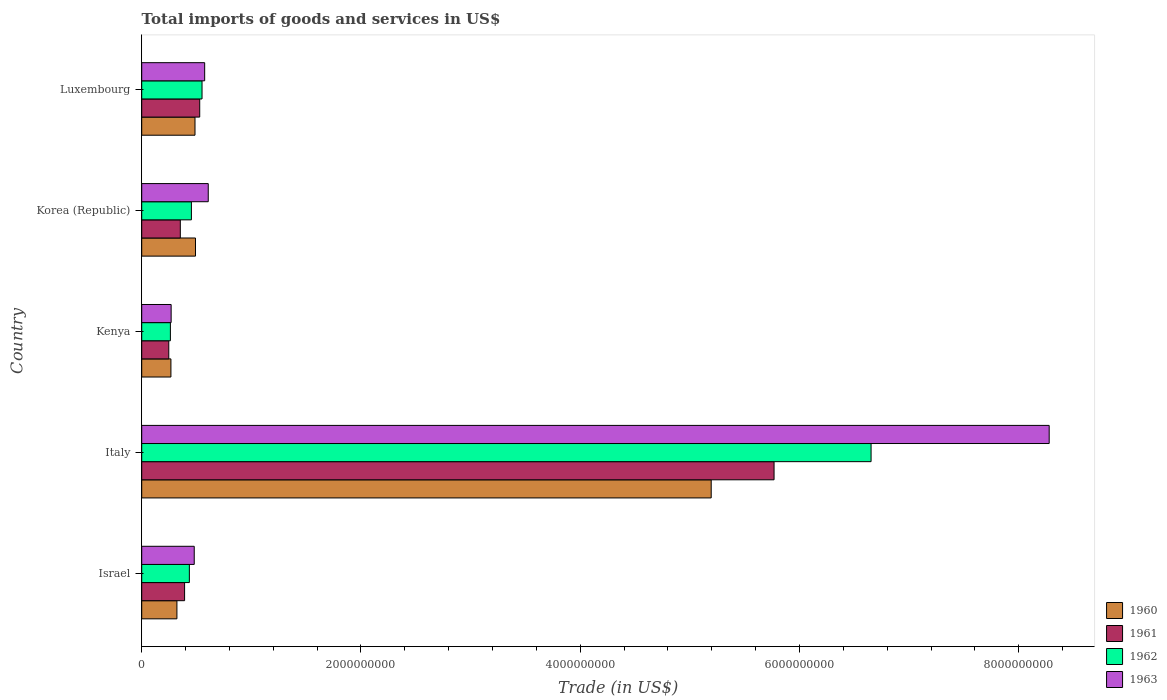How many different coloured bars are there?
Make the answer very short. 4. How many groups of bars are there?
Offer a terse response. 5. How many bars are there on the 4th tick from the bottom?
Keep it short and to the point. 4. What is the label of the 3rd group of bars from the top?
Your answer should be very brief. Kenya. What is the total imports of goods and services in 1960 in Israel?
Give a very brief answer. 3.21e+08. Across all countries, what is the maximum total imports of goods and services in 1963?
Offer a very short reply. 8.28e+09. Across all countries, what is the minimum total imports of goods and services in 1962?
Give a very brief answer. 2.62e+08. In which country was the total imports of goods and services in 1960 maximum?
Give a very brief answer. Italy. In which country was the total imports of goods and services in 1961 minimum?
Your answer should be very brief. Kenya. What is the total total imports of goods and services in 1963 in the graph?
Your response must be concise. 1.02e+1. What is the difference between the total imports of goods and services in 1961 in Kenya and that in Luxembourg?
Your response must be concise. -2.82e+08. What is the difference between the total imports of goods and services in 1962 in Kenya and the total imports of goods and services in 1961 in Korea (Republic)?
Your response must be concise. -9.05e+07. What is the average total imports of goods and services in 1962 per country?
Provide a short and direct response. 1.67e+09. What is the difference between the total imports of goods and services in 1961 and total imports of goods and services in 1960 in Kenya?
Keep it short and to the point. -1.96e+07. In how many countries, is the total imports of goods and services in 1962 greater than 7600000000 US$?
Provide a short and direct response. 0. What is the ratio of the total imports of goods and services in 1962 in Israel to that in Italy?
Your response must be concise. 0.07. Is the total imports of goods and services in 1963 in Kenya less than that in Korea (Republic)?
Give a very brief answer. Yes. Is the difference between the total imports of goods and services in 1961 in Israel and Korea (Republic) greater than the difference between the total imports of goods and services in 1960 in Israel and Korea (Republic)?
Provide a short and direct response. Yes. What is the difference between the highest and the second highest total imports of goods and services in 1960?
Keep it short and to the point. 4.70e+09. What is the difference between the highest and the lowest total imports of goods and services in 1963?
Ensure brevity in your answer.  8.01e+09. Is the sum of the total imports of goods and services in 1960 in Kenya and Korea (Republic) greater than the maximum total imports of goods and services in 1963 across all countries?
Make the answer very short. No. Is it the case that in every country, the sum of the total imports of goods and services in 1962 and total imports of goods and services in 1961 is greater than the sum of total imports of goods and services in 1963 and total imports of goods and services in 1960?
Keep it short and to the point. No. What does the 3rd bar from the top in Kenya represents?
Keep it short and to the point. 1961. Is it the case that in every country, the sum of the total imports of goods and services in 1963 and total imports of goods and services in 1962 is greater than the total imports of goods and services in 1961?
Your answer should be very brief. Yes. How many bars are there?
Your answer should be compact. 20. Are all the bars in the graph horizontal?
Keep it short and to the point. Yes. How many countries are there in the graph?
Offer a terse response. 5. Are the values on the major ticks of X-axis written in scientific E-notation?
Provide a short and direct response. No. Does the graph contain grids?
Your answer should be compact. No. How many legend labels are there?
Offer a very short reply. 4. How are the legend labels stacked?
Provide a succinct answer. Vertical. What is the title of the graph?
Your answer should be compact. Total imports of goods and services in US$. Does "2014" appear as one of the legend labels in the graph?
Your answer should be very brief. No. What is the label or title of the X-axis?
Offer a terse response. Trade (in US$). What is the label or title of the Y-axis?
Provide a short and direct response. Country. What is the Trade (in US$) in 1960 in Israel?
Offer a very short reply. 3.21e+08. What is the Trade (in US$) in 1961 in Israel?
Keep it short and to the point. 3.91e+08. What is the Trade (in US$) of 1962 in Israel?
Provide a succinct answer. 4.34e+08. What is the Trade (in US$) in 1963 in Israel?
Offer a very short reply. 4.79e+08. What is the Trade (in US$) in 1960 in Italy?
Make the answer very short. 5.19e+09. What is the Trade (in US$) in 1961 in Italy?
Provide a succinct answer. 5.77e+09. What is the Trade (in US$) of 1962 in Italy?
Offer a terse response. 6.65e+09. What is the Trade (in US$) of 1963 in Italy?
Your answer should be very brief. 8.28e+09. What is the Trade (in US$) in 1960 in Kenya?
Your answer should be compact. 2.66e+08. What is the Trade (in US$) of 1961 in Kenya?
Your answer should be compact. 2.47e+08. What is the Trade (in US$) of 1962 in Kenya?
Your answer should be very brief. 2.62e+08. What is the Trade (in US$) in 1963 in Kenya?
Give a very brief answer. 2.68e+08. What is the Trade (in US$) of 1960 in Korea (Republic)?
Your answer should be compact. 4.90e+08. What is the Trade (in US$) of 1961 in Korea (Republic)?
Offer a very short reply. 3.52e+08. What is the Trade (in US$) of 1962 in Korea (Republic)?
Offer a very short reply. 4.53e+08. What is the Trade (in US$) in 1963 in Korea (Republic)?
Offer a terse response. 6.07e+08. What is the Trade (in US$) in 1960 in Luxembourg?
Your response must be concise. 4.86e+08. What is the Trade (in US$) of 1961 in Luxembourg?
Provide a short and direct response. 5.29e+08. What is the Trade (in US$) of 1962 in Luxembourg?
Your answer should be compact. 5.50e+08. What is the Trade (in US$) in 1963 in Luxembourg?
Give a very brief answer. 5.74e+08. Across all countries, what is the maximum Trade (in US$) in 1960?
Give a very brief answer. 5.19e+09. Across all countries, what is the maximum Trade (in US$) in 1961?
Keep it short and to the point. 5.77e+09. Across all countries, what is the maximum Trade (in US$) in 1962?
Ensure brevity in your answer.  6.65e+09. Across all countries, what is the maximum Trade (in US$) of 1963?
Give a very brief answer. 8.28e+09. Across all countries, what is the minimum Trade (in US$) of 1960?
Offer a terse response. 2.66e+08. Across all countries, what is the minimum Trade (in US$) in 1961?
Provide a succinct answer. 2.47e+08. Across all countries, what is the minimum Trade (in US$) of 1962?
Offer a terse response. 2.62e+08. Across all countries, what is the minimum Trade (in US$) in 1963?
Ensure brevity in your answer.  2.68e+08. What is the total Trade (in US$) in 1960 in the graph?
Offer a terse response. 6.76e+09. What is the total Trade (in US$) in 1961 in the graph?
Offer a terse response. 7.29e+09. What is the total Trade (in US$) in 1962 in the graph?
Make the answer very short. 8.35e+09. What is the total Trade (in US$) in 1963 in the graph?
Keep it short and to the point. 1.02e+1. What is the difference between the Trade (in US$) of 1960 in Israel and that in Italy?
Offer a terse response. -4.87e+09. What is the difference between the Trade (in US$) of 1961 in Israel and that in Italy?
Your response must be concise. -5.38e+09. What is the difference between the Trade (in US$) in 1962 in Israel and that in Italy?
Give a very brief answer. -6.22e+09. What is the difference between the Trade (in US$) of 1963 in Israel and that in Italy?
Provide a succinct answer. -7.80e+09. What is the difference between the Trade (in US$) in 1960 in Israel and that in Kenya?
Your response must be concise. 5.47e+07. What is the difference between the Trade (in US$) of 1961 in Israel and that in Kenya?
Provide a succinct answer. 1.44e+08. What is the difference between the Trade (in US$) in 1962 in Israel and that in Kenya?
Give a very brief answer. 1.73e+08. What is the difference between the Trade (in US$) in 1963 in Israel and that in Kenya?
Make the answer very short. 2.11e+08. What is the difference between the Trade (in US$) of 1960 in Israel and that in Korea (Republic)?
Offer a very short reply. -1.69e+08. What is the difference between the Trade (in US$) in 1961 in Israel and that in Korea (Republic)?
Provide a succinct answer. 3.90e+07. What is the difference between the Trade (in US$) of 1962 in Israel and that in Korea (Republic)?
Give a very brief answer. -1.87e+07. What is the difference between the Trade (in US$) of 1963 in Israel and that in Korea (Republic)?
Your answer should be compact. -1.28e+08. What is the difference between the Trade (in US$) of 1960 in Israel and that in Luxembourg?
Ensure brevity in your answer.  -1.65e+08. What is the difference between the Trade (in US$) in 1961 in Israel and that in Luxembourg?
Provide a short and direct response. -1.38e+08. What is the difference between the Trade (in US$) of 1962 in Israel and that in Luxembourg?
Make the answer very short. -1.16e+08. What is the difference between the Trade (in US$) in 1963 in Israel and that in Luxembourg?
Your response must be concise. -9.52e+07. What is the difference between the Trade (in US$) in 1960 in Italy and that in Kenya?
Keep it short and to the point. 4.93e+09. What is the difference between the Trade (in US$) in 1961 in Italy and that in Kenya?
Your answer should be compact. 5.52e+09. What is the difference between the Trade (in US$) of 1962 in Italy and that in Kenya?
Make the answer very short. 6.39e+09. What is the difference between the Trade (in US$) in 1963 in Italy and that in Kenya?
Keep it short and to the point. 8.01e+09. What is the difference between the Trade (in US$) in 1960 in Italy and that in Korea (Republic)?
Offer a very short reply. 4.70e+09. What is the difference between the Trade (in US$) of 1961 in Italy and that in Korea (Republic)?
Your response must be concise. 5.42e+09. What is the difference between the Trade (in US$) of 1962 in Italy and that in Korea (Republic)?
Your answer should be very brief. 6.20e+09. What is the difference between the Trade (in US$) in 1963 in Italy and that in Korea (Republic)?
Give a very brief answer. 7.67e+09. What is the difference between the Trade (in US$) in 1960 in Italy and that in Luxembourg?
Provide a short and direct response. 4.71e+09. What is the difference between the Trade (in US$) of 1961 in Italy and that in Luxembourg?
Ensure brevity in your answer.  5.24e+09. What is the difference between the Trade (in US$) in 1962 in Italy and that in Luxembourg?
Keep it short and to the point. 6.10e+09. What is the difference between the Trade (in US$) in 1963 in Italy and that in Luxembourg?
Keep it short and to the point. 7.70e+09. What is the difference between the Trade (in US$) of 1960 in Kenya and that in Korea (Republic)?
Provide a succinct answer. -2.24e+08. What is the difference between the Trade (in US$) in 1961 in Kenya and that in Korea (Republic)?
Ensure brevity in your answer.  -1.05e+08. What is the difference between the Trade (in US$) of 1962 in Kenya and that in Korea (Republic)?
Offer a very short reply. -1.92e+08. What is the difference between the Trade (in US$) of 1963 in Kenya and that in Korea (Republic)?
Offer a very short reply. -3.38e+08. What is the difference between the Trade (in US$) of 1960 in Kenya and that in Luxembourg?
Keep it short and to the point. -2.20e+08. What is the difference between the Trade (in US$) of 1961 in Kenya and that in Luxembourg?
Your response must be concise. -2.82e+08. What is the difference between the Trade (in US$) of 1962 in Kenya and that in Luxembourg?
Give a very brief answer. -2.89e+08. What is the difference between the Trade (in US$) in 1963 in Kenya and that in Luxembourg?
Your answer should be very brief. -3.06e+08. What is the difference between the Trade (in US$) in 1960 in Korea (Republic) and that in Luxembourg?
Provide a short and direct response. 4.40e+06. What is the difference between the Trade (in US$) of 1961 in Korea (Republic) and that in Luxembourg?
Provide a short and direct response. -1.77e+08. What is the difference between the Trade (in US$) of 1962 in Korea (Republic) and that in Luxembourg?
Offer a terse response. -9.70e+07. What is the difference between the Trade (in US$) of 1963 in Korea (Republic) and that in Luxembourg?
Ensure brevity in your answer.  3.26e+07. What is the difference between the Trade (in US$) of 1960 in Israel and the Trade (in US$) of 1961 in Italy?
Offer a terse response. -5.45e+09. What is the difference between the Trade (in US$) of 1960 in Israel and the Trade (in US$) of 1962 in Italy?
Your answer should be very brief. -6.33e+09. What is the difference between the Trade (in US$) of 1960 in Israel and the Trade (in US$) of 1963 in Italy?
Provide a short and direct response. -7.96e+09. What is the difference between the Trade (in US$) of 1961 in Israel and the Trade (in US$) of 1962 in Italy?
Your response must be concise. -6.26e+09. What is the difference between the Trade (in US$) in 1961 in Israel and the Trade (in US$) in 1963 in Italy?
Provide a succinct answer. -7.89e+09. What is the difference between the Trade (in US$) of 1962 in Israel and the Trade (in US$) of 1963 in Italy?
Provide a succinct answer. -7.84e+09. What is the difference between the Trade (in US$) in 1960 in Israel and the Trade (in US$) in 1961 in Kenya?
Offer a very short reply. 7.43e+07. What is the difference between the Trade (in US$) in 1960 in Israel and the Trade (in US$) in 1962 in Kenya?
Provide a short and direct response. 5.96e+07. What is the difference between the Trade (in US$) of 1960 in Israel and the Trade (in US$) of 1963 in Kenya?
Your response must be concise. 5.27e+07. What is the difference between the Trade (in US$) of 1961 in Israel and the Trade (in US$) of 1962 in Kenya?
Your answer should be very brief. 1.30e+08. What is the difference between the Trade (in US$) in 1961 in Israel and the Trade (in US$) in 1963 in Kenya?
Provide a succinct answer. 1.23e+08. What is the difference between the Trade (in US$) in 1962 in Israel and the Trade (in US$) in 1963 in Kenya?
Offer a terse response. 1.66e+08. What is the difference between the Trade (in US$) in 1960 in Israel and the Trade (in US$) in 1961 in Korea (Republic)?
Offer a very short reply. -3.10e+07. What is the difference between the Trade (in US$) in 1960 in Israel and the Trade (in US$) in 1962 in Korea (Republic)?
Your response must be concise. -1.32e+08. What is the difference between the Trade (in US$) in 1960 in Israel and the Trade (in US$) in 1963 in Korea (Republic)?
Offer a very short reply. -2.86e+08. What is the difference between the Trade (in US$) in 1961 in Israel and the Trade (in US$) in 1962 in Korea (Republic)?
Your answer should be compact. -6.21e+07. What is the difference between the Trade (in US$) in 1961 in Israel and the Trade (in US$) in 1963 in Korea (Republic)?
Offer a terse response. -2.16e+08. What is the difference between the Trade (in US$) of 1962 in Israel and the Trade (in US$) of 1963 in Korea (Republic)?
Offer a very short reply. -1.72e+08. What is the difference between the Trade (in US$) in 1960 in Israel and the Trade (in US$) in 1961 in Luxembourg?
Make the answer very short. -2.08e+08. What is the difference between the Trade (in US$) of 1960 in Israel and the Trade (in US$) of 1962 in Luxembourg?
Make the answer very short. -2.29e+08. What is the difference between the Trade (in US$) of 1960 in Israel and the Trade (in US$) of 1963 in Luxembourg?
Keep it short and to the point. -2.53e+08. What is the difference between the Trade (in US$) in 1961 in Israel and the Trade (in US$) in 1962 in Luxembourg?
Ensure brevity in your answer.  -1.59e+08. What is the difference between the Trade (in US$) in 1961 in Israel and the Trade (in US$) in 1963 in Luxembourg?
Offer a terse response. -1.83e+08. What is the difference between the Trade (in US$) in 1962 in Israel and the Trade (in US$) in 1963 in Luxembourg?
Make the answer very short. -1.40e+08. What is the difference between the Trade (in US$) in 1960 in Italy and the Trade (in US$) in 1961 in Kenya?
Your answer should be compact. 4.95e+09. What is the difference between the Trade (in US$) of 1960 in Italy and the Trade (in US$) of 1962 in Kenya?
Offer a very short reply. 4.93e+09. What is the difference between the Trade (in US$) in 1960 in Italy and the Trade (in US$) in 1963 in Kenya?
Make the answer very short. 4.93e+09. What is the difference between the Trade (in US$) of 1961 in Italy and the Trade (in US$) of 1962 in Kenya?
Give a very brief answer. 5.51e+09. What is the difference between the Trade (in US$) in 1961 in Italy and the Trade (in US$) in 1963 in Kenya?
Your answer should be very brief. 5.50e+09. What is the difference between the Trade (in US$) in 1962 in Italy and the Trade (in US$) in 1963 in Kenya?
Your answer should be compact. 6.38e+09. What is the difference between the Trade (in US$) in 1960 in Italy and the Trade (in US$) in 1961 in Korea (Republic)?
Offer a terse response. 4.84e+09. What is the difference between the Trade (in US$) in 1960 in Italy and the Trade (in US$) in 1962 in Korea (Republic)?
Give a very brief answer. 4.74e+09. What is the difference between the Trade (in US$) of 1960 in Italy and the Trade (in US$) of 1963 in Korea (Republic)?
Give a very brief answer. 4.59e+09. What is the difference between the Trade (in US$) of 1961 in Italy and the Trade (in US$) of 1962 in Korea (Republic)?
Provide a short and direct response. 5.31e+09. What is the difference between the Trade (in US$) of 1961 in Italy and the Trade (in US$) of 1963 in Korea (Republic)?
Provide a succinct answer. 5.16e+09. What is the difference between the Trade (in US$) in 1962 in Italy and the Trade (in US$) in 1963 in Korea (Republic)?
Make the answer very short. 6.05e+09. What is the difference between the Trade (in US$) in 1960 in Italy and the Trade (in US$) in 1961 in Luxembourg?
Keep it short and to the point. 4.67e+09. What is the difference between the Trade (in US$) in 1960 in Italy and the Trade (in US$) in 1962 in Luxembourg?
Provide a short and direct response. 4.64e+09. What is the difference between the Trade (in US$) of 1960 in Italy and the Trade (in US$) of 1963 in Luxembourg?
Provide a short and direct response. 4.62e+09. What is the difference between the Trade (in US$) in 1961 in Italy and the Trade (in US$) in 1962 in Luxembourg?
Your response must be concise. 5.22e+09. What is the difference between the Trade (in US$) of 1961 in Italy and the Trade (in US$) of 1963 in Luxembourg?
Offer a terse response. 5.19e+09. What is the difference between the Trade (in US$) of 1962 in Italy and the Trade (in US$) of 1963 in Luxembourg?
Make the answer very short. 6.08e+09. What is the difference between the Trade (in US$) in 1960 in Kenya and the Trade (in US$) in 1961 in Korea (Republic)?
Your answer should be very brief. -8.56e+07. What is the difference between the Trade (in US$) of 1960 in Kenya and the Trade (in US$) of 1962 in Korea (Republic)?
Ensure brevity in your answer.  -1.87e+08. What is the difference between the Trade (in US$) of 1960 in Kenya and the Trade (in US$) of 1963 in Korea (Republic)?
Ensure brevity in your answer.  -3.40e+08. What is the difference between the Trade (in US$) of 1961 in Kenya and the Trade (in US$) of 1962 in Korea (Republic)?
Make the answer very short. -2.06e+08. What is the difference between the Trade (in US$) of 1961 in Kenya and the Trade (in US$) of 1963 in Korea (Republic)?
Provide a short and direct response. -3.60e+08. What is the difference between the Trade (in US$) in 1962 in Kenya and the Trade (in US$) in 1963 in Korea (Republic)?
Make the answer very short. -3.45e+08. What is the difference between the Trade (in US$) in 1960 in Kenya and the Trade (in US$) in 1961 in Luxembourg?
Your answer should be compact. -2.63e+08. What is the difference between the Trade (in US$) of 1960 in Kenya and the Trade (in US$) of 1962 in Luxembourg?
Give a very brief answer. -2.84e+08. What is the difference between the Trade (in US$) in 1960 in Kenya and the Trade (in US$) in 1963 in Luxembourg?
Keep it short and to the point. -3.08e+08. What is the difference between the Trade (in US$) of 1961 in Kenya and the Trade (in US$) of 1962 in Luxembourg?
Your answer should be compact. -3.03e+08. What is the difference between the Trade (in US$) in 1961 in Kenya and the Trade (in US$) in 1963 in Luxembourg?
Provide a succinct answer. -3.27e+08. What is the difference between the Trade (in US$) in 1962 in Kenya and the Trade (in US$) in 1963 in Luxembourg?
Your answer should be compact. -3.13e+08. What is the difference between the Trade (in US$) of 1960 in Korea (Republic) and the Trade (in US$) of 1961 in Luxembourg?
Offer a very short reply. -3.87e+07. What is the difference between the Trade (in US$) of 1960 in Korea (Republic) and the Trade (in US$) of 1962 in Luxembourg?
Your response must be concise. -5.98e+07. What is the difference between the Trade (in US$) in 1960 in Korea (Republic) and the Trade (in US$) in 1963 in Luxembourg?
Keep it short and to the point. -8.39e+07. What is the difference between the Trade (in US$) of 1961 in Korea (Republic) and the Trade (in US$) of 1962 in Luxembourg?
Give a very brief answer. -1.98e+08. What is the difference between the Trade (in US$) in 1961 in Korea (Republic) and the Trade (in US$) in 1963 in Luxembourg?
Offer a very short reply. -2.22e+08. What is the difference between the Trade (in US$) of 1962 in Korea (Republic) and the Trade (in US$) of 1963 in Luxembourg?
Your response must be concise. -1.21e+08. What is the average Trade (in US$) of 1960 per country?
Provide a short and direct response. 1.35e+09. What is the average Trade (in US$) of 1961 per country?
Your response must be concise. 1.46e+09. What is the average Trade (in US$) in 1962 per country?
Your answer should be very brief. 1.67e+09. What is the average Trade (in US$) in 1963 per country?
Ensure brevity in your answer.  2.04e+09. What is the difference between the Trade (in US$) in 1960 and Trade (in US$) in 1961 in Israel?
Your answer should be compact. -7.00e+07. What is the difference between the Trade (in US$) of 1960 and Trade (in US$) of 1962 in Israel?
Provide a short and direct response. -1.13e+08. What is the difference between the Trade (in US$) of 1960 and Trade (in US$) of 1963 in Israel?
Ensure brevity in your answer.  -1.58e+08. What is the difference between the Trade (in US$) in 1961 and Trade (in US$) in 1962 in Israel?
Your answer should be compact. -4.34e+07. What is the difference between the Trade (in US$) in 1961 and Trade (in US$) in 1963 in Israel?
Make the answer very short. -8.79e+07. What is the difference between the Trade (in US$) in 1962 and Trade (in US$) in 1963 in Israel?
Provide a short and direct response. -4.45e+07. What is the difference between the Trade (in US$) of 1960 and Trade (in US$) of 1961 in Italy?
Keep it short and to the point. -5.73e+08. What is the difference between the Trade (in US$) in 1960 and Trade (in US$) in 1962 in Italy?
Offer a terse response. -1.46e+09. What is the difference between the Trade (in US$) in 1960 and Trade (in US$) in 1963 in Italy?
Offer a terse response. -3.08e+09. What is the difference between the Trade (in US$) in 1961 and Trade (in US$) in 1962 in Italy?
Give a very brief answer. -8.85e+08. What is the difference between the Trade (in US$) in 1961 and Trade (in US$) in 1963 in Italy?
Give a very brief answer. -2.51e+09. What is the difference between the Trade (in US$) of 1962 and Trade (in US$) of 1963 in Italy?
Provide a succinct answer. -1.62e+09. What is the difference between the Trade (in US$) in 1960 and Trade (in US$) in 1961 in Kenya?
Offer a terse response. 1.96e+07. What is the difference between the Trade (in US$) in 1960 and Trade (in US$) in 1962 in Kenya?
Keep it short and to the point. 4.90e+06. What is the difference between the Trade (in US$) in 1960 and Trade (in US$) in 1963 in Kenya?
Ensure brevity in your answer.  -1.95e+06. What is the difference between the Trade (in US$) in 1961 and Trade (in US$) in 1962 in Kenya?
Provide a short and direct response. -1.47e+07. What is the difference between the Trade (in US$) of 1961 and Trade (in US$) of 1963 in Kenya?
Ensure brevity in your answer.  -2.15e+07. What is the difference between the Trade (in US$) in 1962 and Trade (in US$) in 1963 in Kenya?
Offer a very short reply. -6.85e+06. What is the difference between the Trade (in US$) of 1960 and Trade (in US$) of 1961 in Korea (Republic)?
Keep it short and to the point. 1.38e+08. What is the difference between the Trade (in US$) in 1960 and Trade (in US$) in 1962 in Korea (Republic)?
Make the answer very short. 3.72e+07. What is the difference between the Trade (in US$) of 1960 and Trade (in US$) of 1963 in Korea (Republic)?
Provide a succinct answer. -1.16e+08. What is the difference between the Trade (in US$) in 1961 and Trade (in US$) in 1962 in Korea (Republic)?
Ensure brevity in your answer.  -1.01e+08. What is the difference between the Trade (in US$) in 1961 and Trade (in US$) in 1963 in Korea (Republic)?
Your response must be concise. -2.55e+08. What is the difference between the Trade (in US$) in 1962 and Trade (in US$) in 1963 in Korea (Republic)?
Provide a succinct answer. -1.54e+08. What is the difference between the Trade (in US$) of 1960 and Trade (in US$) of 1961 in Luxembourg?
Your answer should be very brief. -4.31e+07. What is the difference between the Trade (in US$) of 1960 and Trade (in US$) of 1962 in Luxembourg?
Your answer should be compact. -6.42e+07. What is the difference between the Trade (in US$) of 1960 and Trade (in US$) of 1963 in Luxembourg?
Make the answer very short. -8.83e+07. What is the difference between the Trade (in US$) of 1961 and Trade (in US$) of 1962 in Luxembourg?
Your answer should be very brief. -2.10e+07. What is the difference between the Trade (in US$) of 1961 and Trade (in US$) of 1963 in Luxembourg?
Make the answer very short. -4.51e+07. What is the difference between the Trade (in US$) of 1962 and Trade (in US$) of 1963 in Luxembourg?
Provide a succinct answer. -2.41e+07. What is the ratio of the Trade (in US$) of 1960 in Israel to that in Italy?
Your answer should be very brief. 0.06. What is the ratio of the Trade (in US$) of 1961 in Israel to that in Italy?
Make the answer very short. 0.07. What is the ratio of the Trade (in US$) of 1962 in Israel to that in Italy?
Make the answer very short. 0.07. What is the ratio of the Trade (in US$) of 1963 in Israel to that in Italy?
Ensure brevity in your answer.  0.06. What is the ratio of the Trade (in US$) of 1960 in Israel to that in Kenya?
Give a very brief answer. 1.21. What is the ratio of the Trade (in US$) in 1961 in Israel to that in Kenya?
Give a very brief answer. 1.58. What is the ratio of the Trade (in US$) of 1962 in Israel to that in Kenya?
Make the answer very short. 1.66. What is the ratio of the Trade (in US$) of 1963 in Israel to that in Kenya?
Provide a short and direct response. 1.78. What is the ratio of the Trade (in US$) of 1960 in Israel to that in Korea (Republic)?
Your answer should be compact. 0.65. What is the ratio of the Trade (in US$) of 1961 in Israel to that in Korea (Republic)?
Offer a terse response. 1.11. What is the ratio of the Trade (in US$) of 1962 in Israel to that in Korea (Republic)?
Provide a succinct answer. 0.96. What is the ratio of the Trade (in US$) of 1963 in Israel to that in Korea (Republic)?
Give a very brief answer. 0.79. What is the ratio of the Trade (in US$) in 1960 in Israel to that in Luxembourg?
Give a very brief answer. 0.66. What is the ratio of the Trade (in US$) of 1961 in Israel to that in Luxembourg?
Ensure brevity in your answer.  0.74. What is the ratio of the Trade (in US$) in 1962 in Israel to that in Luxembourg?
Give a very brief answer. 0.79. What is the ratio of the Trade (in US$) in 1963 in Israel to that in Luxembourg?
Keep it short and to the point. 0.83. What is the ratio of the Trade (in US$) of 1960 in Italy to that in Kenya?
Keep it short and to the point. 19.5. What is the ratio of the Trade (in US$) of 1961 in Italy to that in Kenya?
Provide a short and direct response. 23.37. What is the ratio of the Trade (in US$) of 1962 in Italy to that in Kenya?
Offer a terse response. 25.44. What is the ratio of the Trade (in US$) of 1963 in Italy to that in Kenya?
Your answer should be very brief. 30.85. What is the ratio of the Trade (in US$) in 1960 in Italy to that in Korea (Republic)?
Make the answer very short. 10.59. What is the ratio of the Trade (in US$) of 1961 in Italy to that in Korea (Republic)?
Provide a succinct answer. 16.38. What is the ratio of the Trade (in US$) in 1962 in Italy to that in Korea (Republic)?
Your answer should be very brief. 14.68. What is the ratio of the Trade (in US$) of 1963 in Italy to that in Korea (Republic)?
Ensure brevity in your answer.  13.64. What is the ratio of the Trade (in US$) in 1960 in Italy to that in Luxembourg?
Give a very brief answer. 10.69. What is the ratio of the Trade (in US$) in 1961 in Italy to that in Luxembourg?
Keep it short and to the point. 10.9. What is the ratio of the Trade (in US$) in 1962 in Italy to that in Luxembourg?
Provide a succinct answer. 12.09. What is the ratio of the Trade (in US$) in 1963 in Italy to that in Luxembourg?
Offer a very short reply. 14.42. What is the ratio of the Trade (in US$) in 1960 in Kenya to that in Korea (Republic)?
Offer a very short reply. 0.54. What is the ratio of the Trade (in US$) of 1961 in Kenya to that in Korea (Republic)?
Provide a short and direct response. 0.7. What is the ratio of the Trade (in US$) in 1962 in Kenya to that in Korea (Republic)?
Keep it short and to the point. 0.58. What is the ratio of the Trade (in US$) in 1963 in Kenya to that in Korea (Republic)?
Keep it short and to the point. 0.44. What is the ratio of the Trade (in US$) of 1960 in Kenya to that in Luxembourg?
Provide a succinct answer. 0.55. What is the ratio of the Trade (in US$) of 1961 in Kenya to that in Luxembourg?
Provide a succinct answer. 0.47. What is the ratio of the Trade (in US$) of 1962 in Kenya to that in Luxembourg?
Provide a short and direct response. 0.48. What is the ratio of the Trade (in US$) of 1963 in Kenya to that in Luxembourg?
Provide a succinct answer. 0.47. What is the ratio of the Trade (in US$) in 1960 in Korea (Republic) to that in Luxembourg?
Your response must be concise. 1.01. What is the ratio of the Trade (in US$) in 1961 in Korea (Republic) to that in Luxembourg?
Your response must be concise. 0.67. What is the ratio of the Trade (in US$) in 1962 in Korea (Republic) to that in Luxembourg?
Your response must be concise. 0.82. What is the ratio of the Trade (in US$) in 1963 in Korea (Republic) to that in Luxembourg?
Offer a very short reply. 1.06. What is the difference between the highest and the second highest Trade (in US$) of 1960?
Keep it short and to the point. 4.70e+09. What is the difference between the highest and the second highest Trade (in US$) in 1961?
Your answer should be compact. 5.24e+09. What is the difference between the highest and the second highest Trade (in US$) of 1962?
Your answer should be very brief. 6.10e+09. What is the difference between the highest and the second highest Trade (in US$) in 1963?
Provide a succinct answer. 7.67e+09. What is the difference between the highest and the lowest Trade (in US$) in 1960?
Provide a short and direct response. 4.93e+09. What is the difference between the highest and the lowest Trade (in US$) of 1961?
Provide a succinct answer. 5.52e+09. What is the difference between the highest and the lowest Trade (in US$) of 1962?
Keep it short and to the point. 6.39e+09. What is the difference between the highest and the lowest Trade (in US$) of 1963?
Keep it short and to the point. 8.01e+09. 